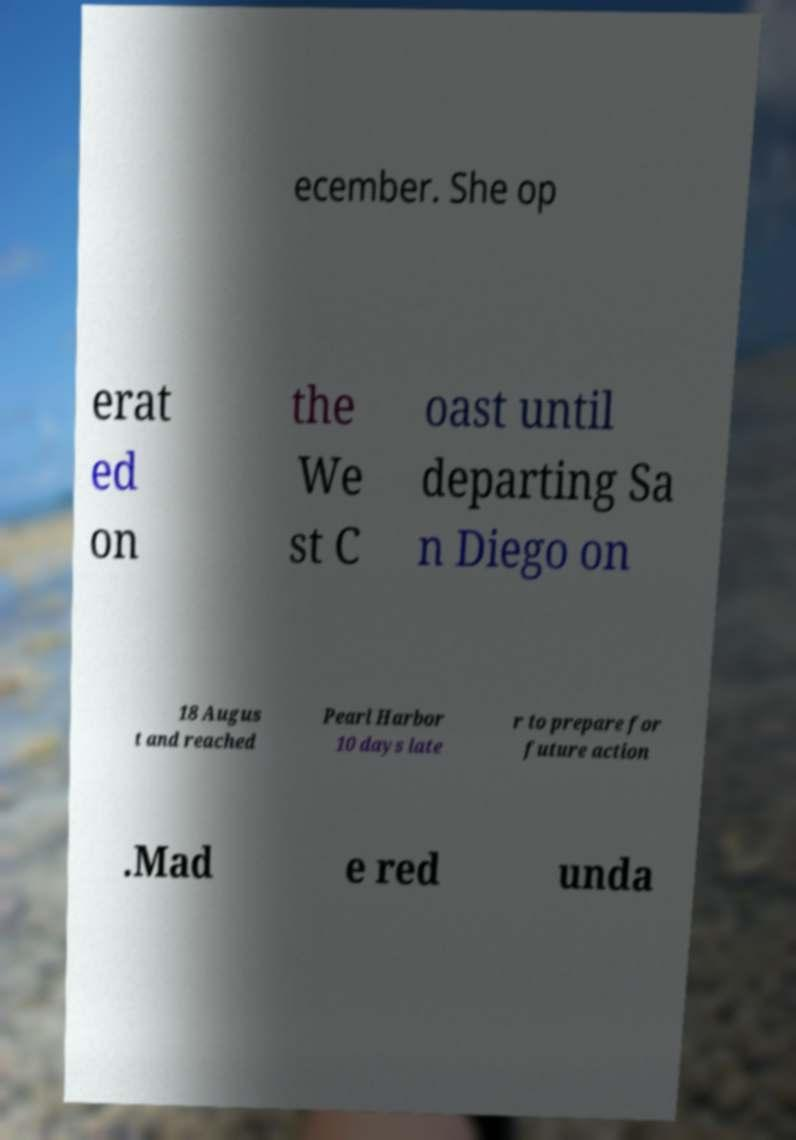Could you assist in decoding the text presented in this image and type it out clearly? ecember. She op erat ed on the We st C oast until departing Sa n Diego on 18 Augus t and reached Pearl Harbor 10 days late r to prepare for future action .Mad e red unda 